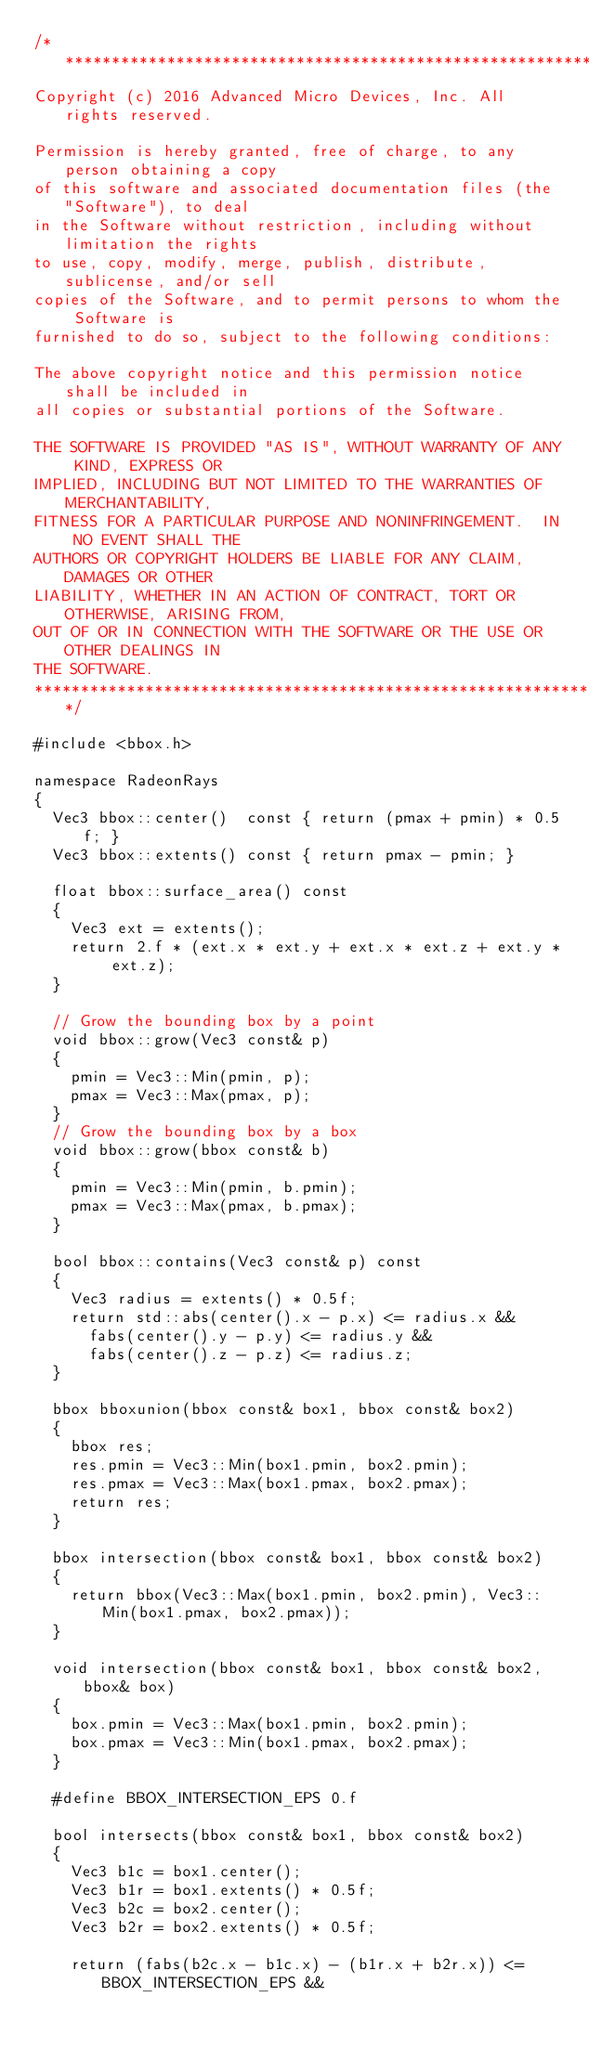<code> <loc_0><loc_0><loc_500><loc_500><_C++_>/**********************************************************************
Copyright (c) 2016 Advanced Micro Devices, Inc. All rights reserved.

Permission is hereby granted, free of charge, to any person obtaining a copy
of this software and associated documentation files (the "Software"), to deal
in the Software without restriction, including without limitation the rights
to use, copy, modify, merge, publish, distribute, sublicense, and/or sell
copies of the Software, and to permit persons to whom the Software is
furnished to do so, subject to the following conditions:

The above copyright notice and this permission notice shall be included in
all copies or substantial portions of the Software.

THE SOFTWARE IS PROVIDED "AS IS", WITHOUT WARRANTY OF ANY KIND, EXPRESS OR
IMPLIED, INCLUDING BUT NOT LIMITED TO THE WARRANTIES OF MERCHANTABILITY,
FITNESS FOR A PARTICULAR PURPOSE AND NONINFRINGEMENT.  IN NO EVENT SHALL THE
AUTHORS OR COPYRIGHT HOLDERS BE LIABLE FOR ANY CLAIM, DAMAGES OR OTHER
LIABILITY, WHETHER IN AN ACTION OF CONTRACT, TORT OR OTHERWISE, ARISING FROM,
OUT OF OR IN CONNECTION WITH THE SOFTWARE OR THE USE OR OTHER DEALINGS IN
THE SOFTWARE.
********************************************************************/

#include <bbox.h>

namespace RadeonRays
{
	Vec3 bbox::center()  const { return (pmax + pmin) * 0.5f; }
	Vec3 bbox::extents() const { return pmax - pmin; }

	float bbox::surface_area() const
	{
		Vec3 ext = extents();
		return 2.f * (ext.x * ext.y + ext.x * ext.z + ext.y * ext.z);
	}

	// Grow the bounding box by a point
	void bbox::grow(Vec3 const& p)
	{
		pmin = Vec3::Min(pmin, p);
		pmax = Vec3::Max(pmax, p);
	}
	// Grow the bounding box by a box
	void bbox::grow(bbox const& b)
	{
		pmin = Vec3::Min(pmin, b.pmin);
		pmax = Vec3::Max(pmax, b.pmax);
	}

	bool bbox::contains(Vec3 const& p) const
	{
		Vec3 radius = extents() * 0.5f;
		return std::abs(center().x - p.x) <= radius.x &&
			fabs(center().y - p.y) <= radius.y &&
			fabs(center().z - p.z) <= radius.z;
	}

	bbox bboxunion(bbox const& box1, bbox const& box2)
	{
		bbox res;
		res.pmin = Vec3::Min(box1.pmin, box2.pmin);
		res.pmax = Vec3::Max(box1.pmax, box2.pmax);
		return res;
	}

	bbox intersection(bbox const& box1, bbox const& box2)
	{
		return bbox(Vec3::Max(box1.pmin, box2.pmin), Vec3::Min(box1.pmax, box2.pmax));
	}

	void intersection(bbox const& box1, bbox const& box2, bbox& box)
	{
		box.pmin = Vec3::Max(box1.pmin, box2.pmin);
		box.pmax = Vec3::Min(box1.pmax, box2.pmax);
	}

	#define BBOX_INTERSECTION_EPS 0.f

	bool intersects(bbox const& box1, bbox const& box2)
	{
		Vec3 b1c = box1.center();
		Vec3 b1r = box1.extents() * 0.5f;
		Vec3 b2c = box2.center();
		Vec3 b2r = box2.extents() * 0.5f;

		return (fabs(b2c.x - b1c.x) - (b1r.x + b2r.x)) <= BBOX_INTERSECTION_EPS &&</code> 